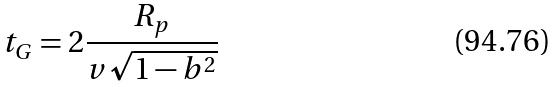Convert formula to latex. <formula><loc_0><loc_0><loc_500><loc_500>t _ { G } = 2 \frac { R _ { p } } { v \sqrt { 1 - b ^ { 2 } } }</formula> 